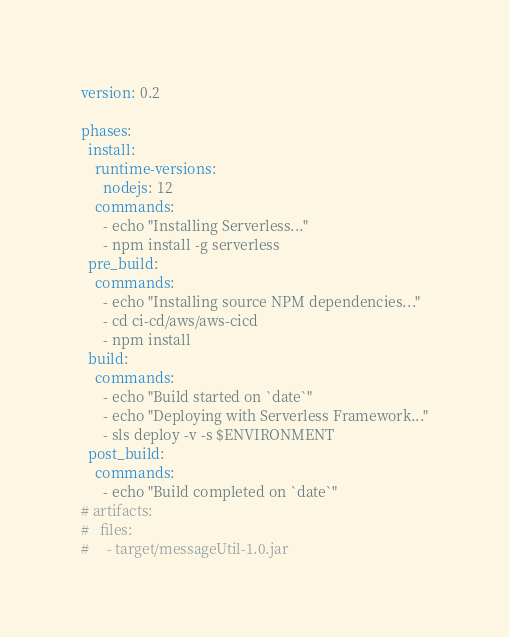Convert code to text. <code><loc_0><loc_0><loc_500><loc_500><_YAML_>version: 0.2

phases:
  install:
    runtime-versions:
      nodejs: 12
    commands:
      - echo "Installing Serverless..."
      - npm install -g serverless
  pre_build:
    commands:
      - echo "Installing source NPM dependencies..."
      - cd ci-cd/aws/aws-cicd
      - npm install
  build:
    commands:
      - echo "Build started on `date`"
      - echo "Deploying with Serverless Framework..."
      - sls deploy -v -s $ENVIRONMENT
  post_build:
    commands:
      - echo "Build completed on `date`"
# artifacts:
#   files:
#     - target/messageUtil-1.0.jar
</code> 